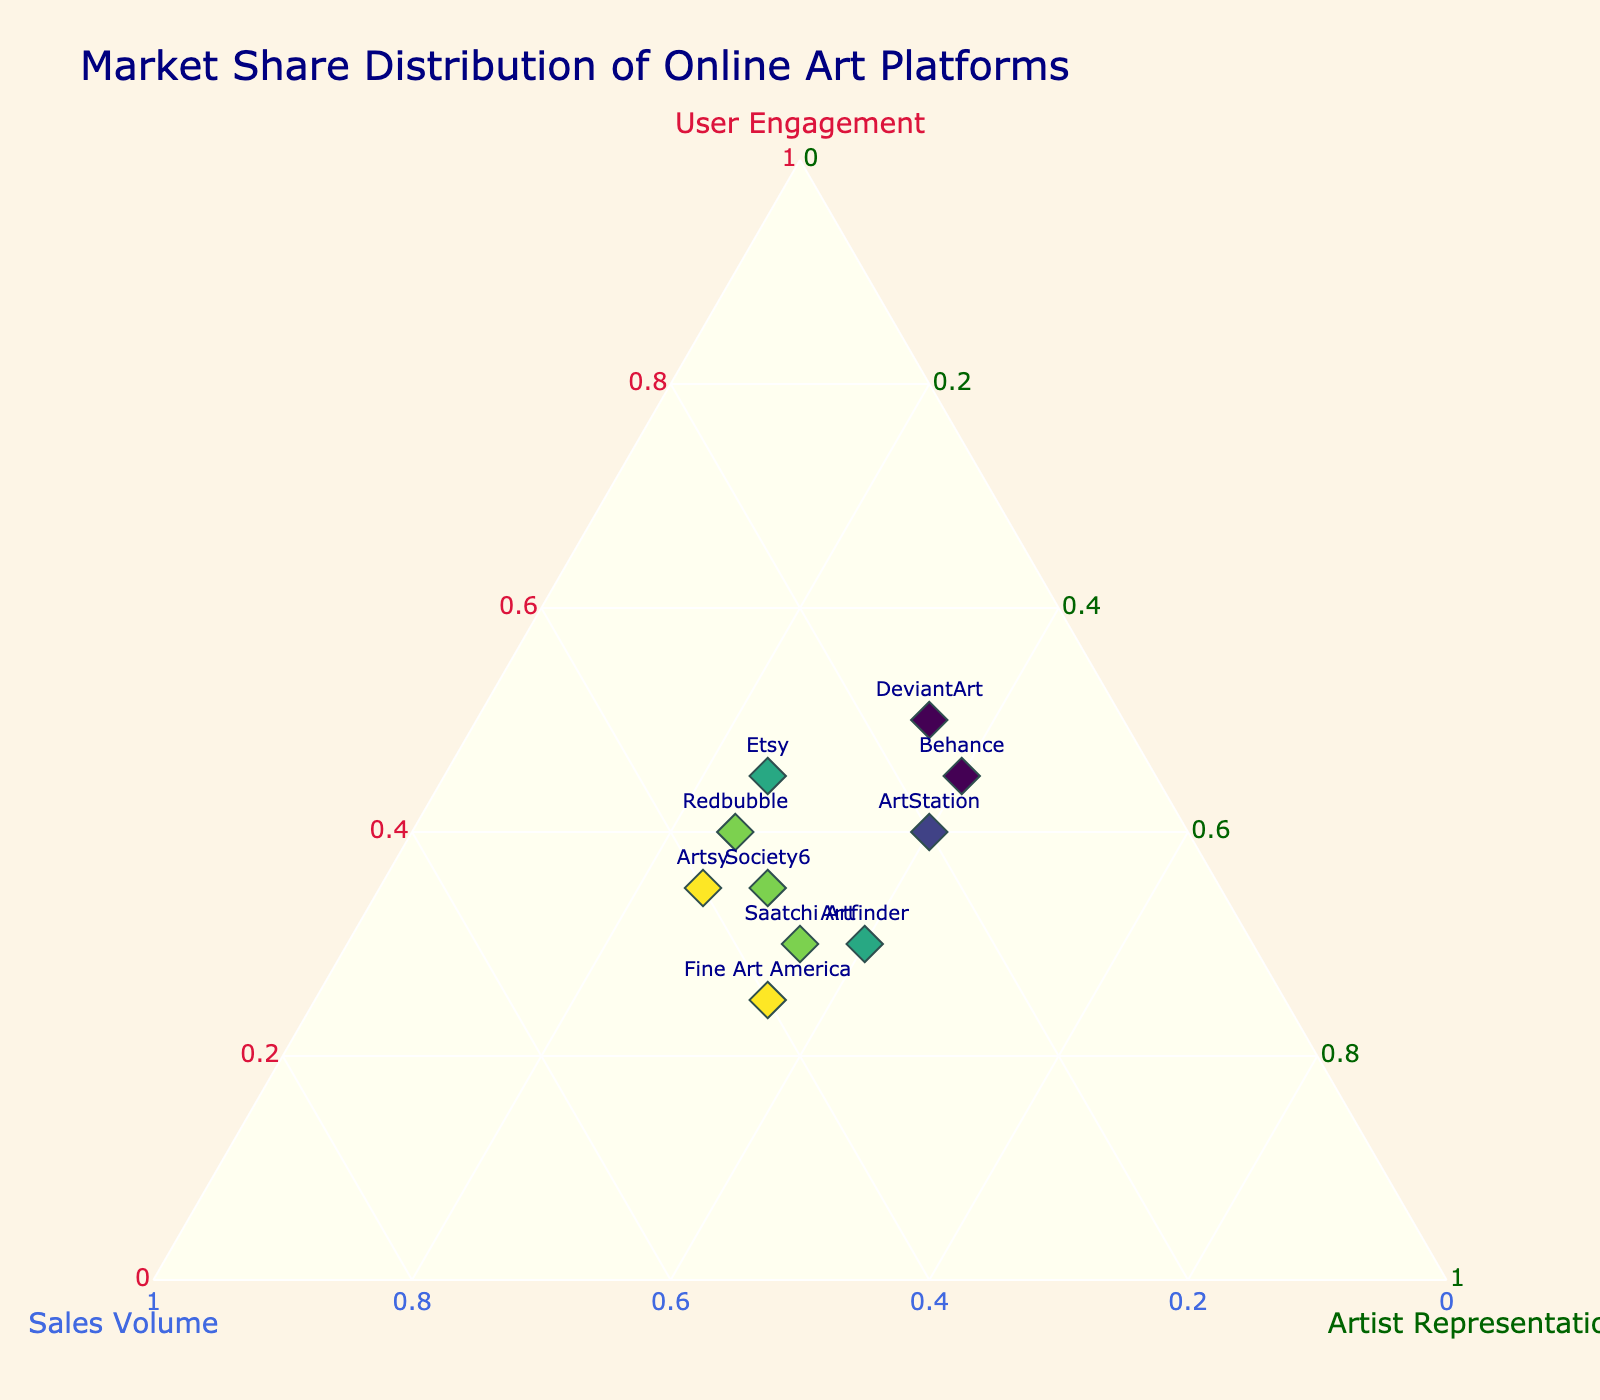Which platform has the highest user engagement? DeviantArt has the highest user engagement with 50%. This can be determined by locating the platform that corresponds to the highest value on the chart along the "User Engagement" axis.
Answer: DeviantArt How many platforms have a sales volume of 40%? To find this, simply count the number of platforms with sales volume at 0.40. Platforms with this value are Artsy and Fine Art America.
Answer: 2 What's the most balanced platform in terms of distribution? The most balanced platform should have similar values in user engagement, sales volume, and artist representation. Artfinder has User Engagement (30%), Sales Volume (30%), and Artist Representation (40%), which are relatively close to each other.
Answer: Artfinder Which platform has the highest artist representation, and how does its sales volume compare to its user engagement? ArtStation and Behance both have the highest artist representation at 40%. ArtStation has a user engagement of 40% and sales volume of 20%, whereas Behance has a user engagement of 45% and sales volume of 15%. By comparing these values, ArtStation has lower user engagement but higher sales volume than Behance.
Answer: ArtStation and Behance Which platform has a higher user engagement: Saatchi Art or Society6? Society6 has a user engagement of 35%, whereas Saatchi Art has a user engagement of 30%. Hence, Society6 has higher user engagement.
Answer: Society6 What is the color scale used in the plot, and which platform appears to be the darkest? The color scale used is Viridis. The color is based on the sales volume, with darker colors representing higher sales volumes. Fine Art America and Artsy with a sales volume of 40% appear to be the darkest.
Answer: Viridis, Artsy and Fine Art America If you were to target platforms with the lowest sales volume for improvement, which platforms would you choose? The platforms with the lowest sales volume of 15% are DeviantArt and Behance. These would be the primary targets for improvement in sales volume.
Answer: DeviantArt and Behance Which platform stands out in user engagement but lags in sales volume? DeviantArt stands out as it has the highest user engagement of 50% but a lower sales volume of 15%. This is evident when cross-referencing the "User Engagement" and "Sales Volume" axes.
Answer: DeviantArt What's the median value of user engagement across all platforms? The user engagement values are 0.35, 0.30, 0.45, 0.50, 0.40, 0.45, 0.25, 0.30, 0.35, and 0.40. Arranging in ascending order: 0.25, 0.30, 0.30, 0.35, 0.35, 0.40, 0.40, 0.45, 0.45, 0.50. Since there are 10 numbers, the median is the average of the 5th and 6th values: (0.35 + 0.40)/2 = 0.375.
Answer: 0.375 